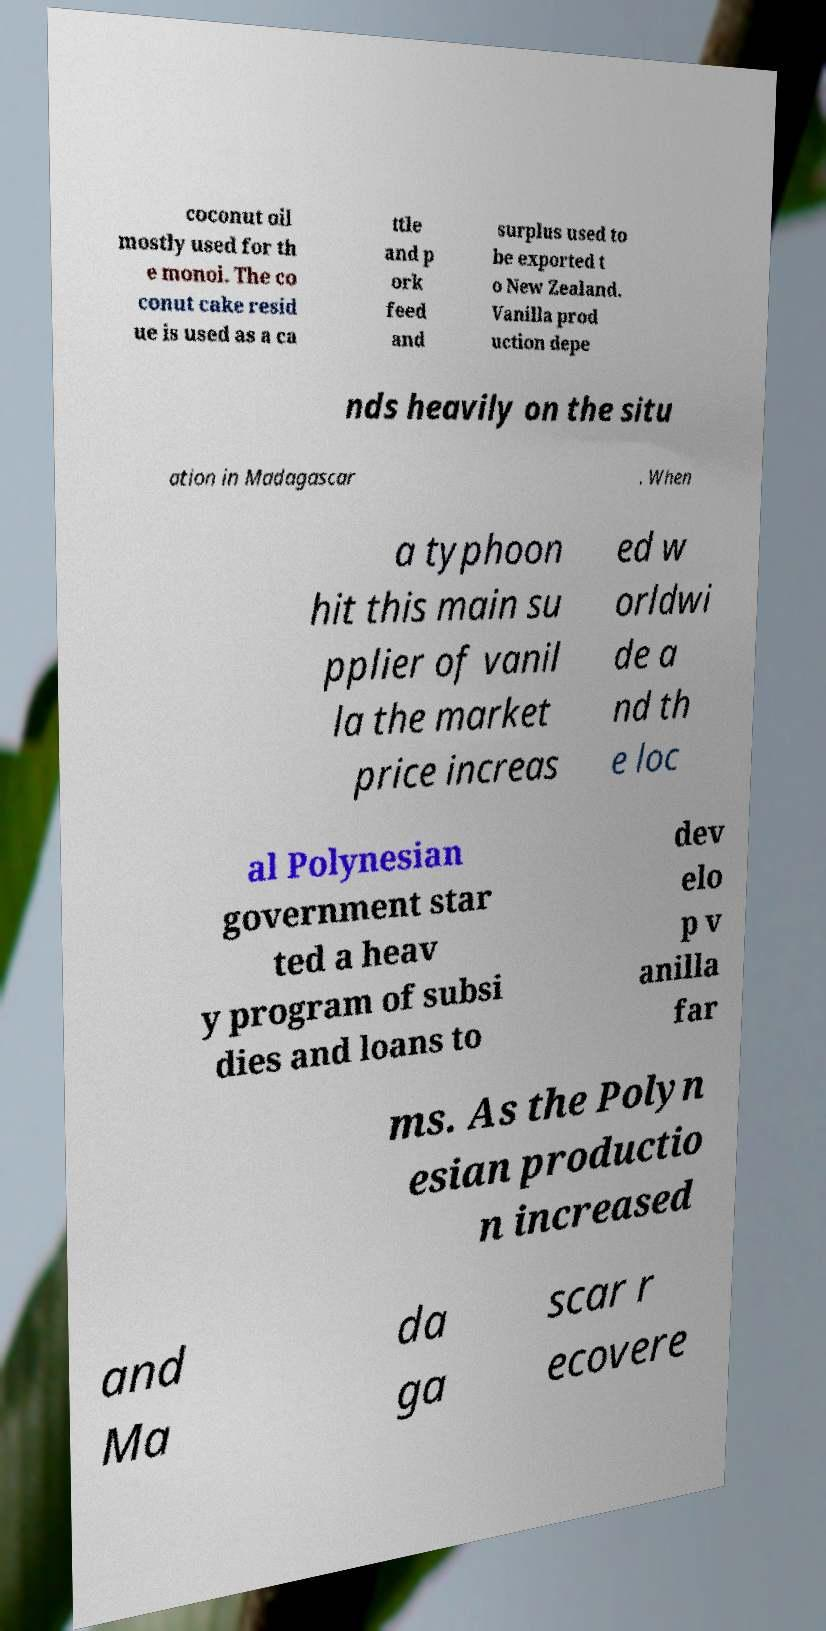Please identify and transcribe the text found in this image. coconut oil mostly used for th e monoi. The co conut cake resid ue is used as a ca ttle and p ork feed and surplus used to be exported t o New Zealand. Vanilla prod uction depe nds heavily on the situ ation in Madagascar . When a typhoon hit this main su pplier of vanil la the market price increas ed w orldwi de a nd th e loc al Polynesian government star ted a heav y program of subsi dies and loans to dev elo p v anilla far ms. As the Polyn esian productio n increased and Ma da ga scar r ecovere 